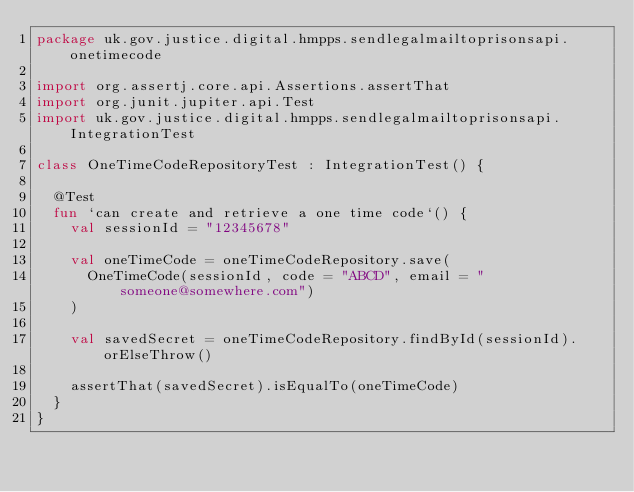Convert code to text. <code><loc_0><loc_0><loc_500><loc_500><_Kotlin_>package uk.gov.justice.digital.hmpps.sendlegalmailtoprisonsapi.onetimecode

import org.assertj.core.api.Assertions.assertThat
import org.junit.jupiter.api.Test
import uk.gov.justice.digital.hmpps.sendlegalmailtoprisonsapi.IntegrationTest

class OneTimeCodeRepositoryTest : IntegrationTest() {

  @Test
  fun `can create and retrieve a one time code`() {
    val sessionId = "12345678"

    val oneTimeCode = oneTimeCodeRepository.save(
      OneTimeCode(sessionId, code = "ABCD", email = "someone@somewhere.com")
    )

    val savedSecret = oneTimeCodeRepository.findById(sessionId).orElseThrow()

    assertThat(savedSecret).isEqualTo(oneTimeCode)
  }
}
</code> 